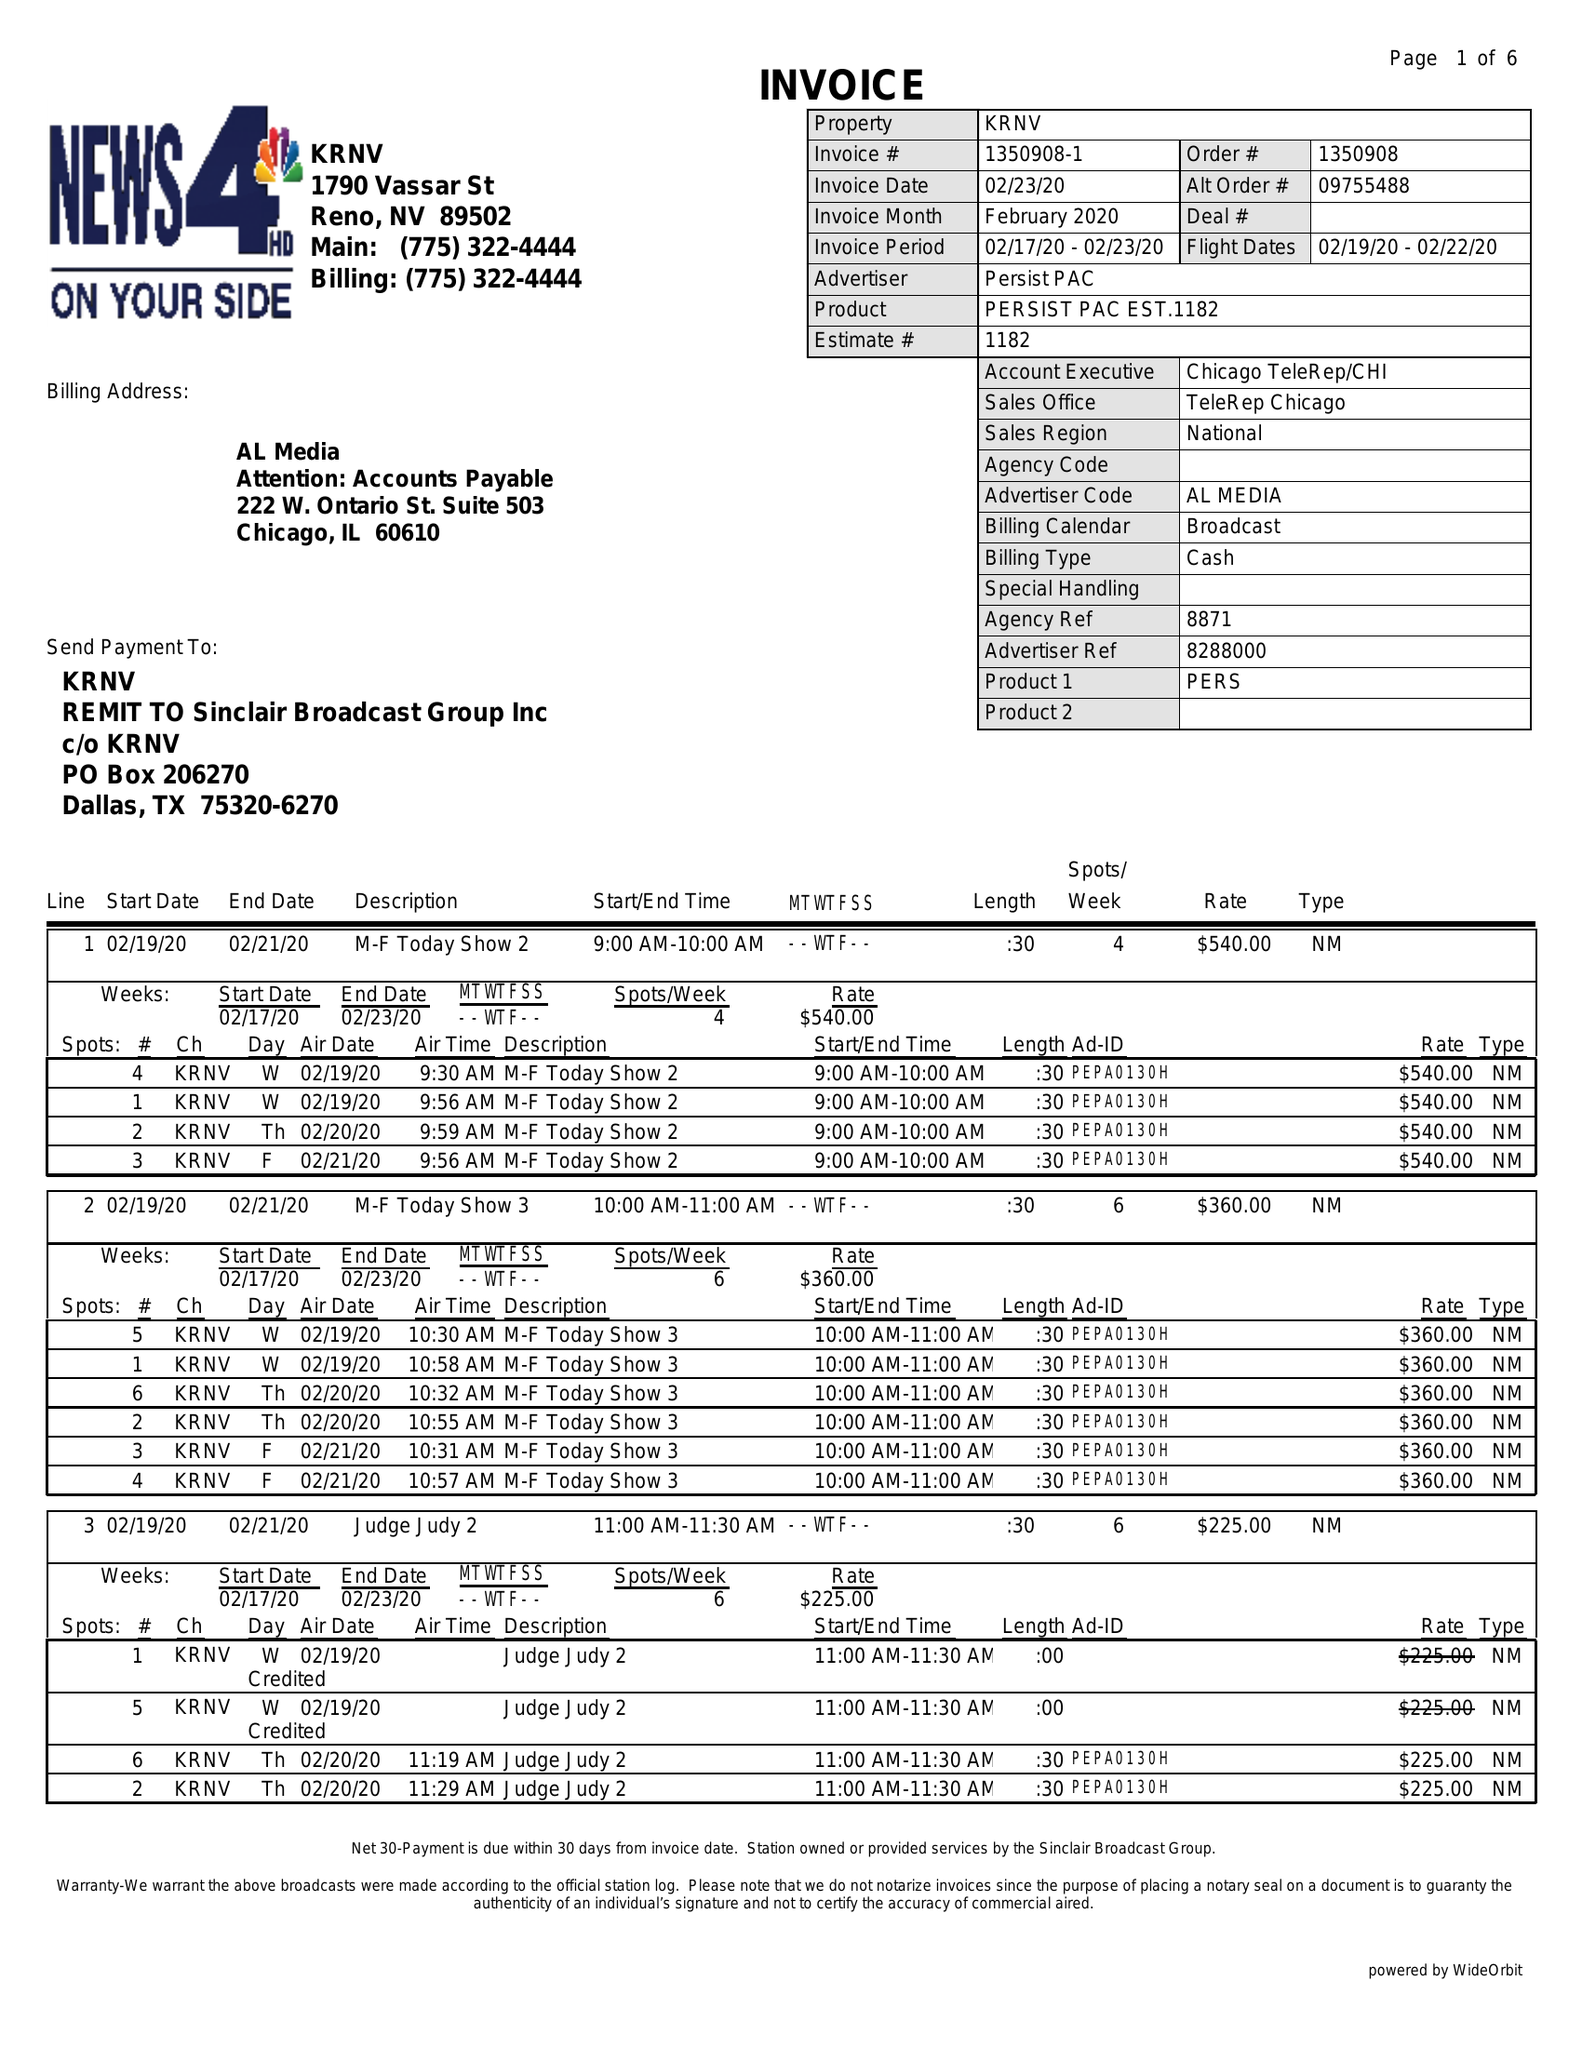What is the value for the advertiser?
Answer the question using a single word or phrase. PERSIST PAC 